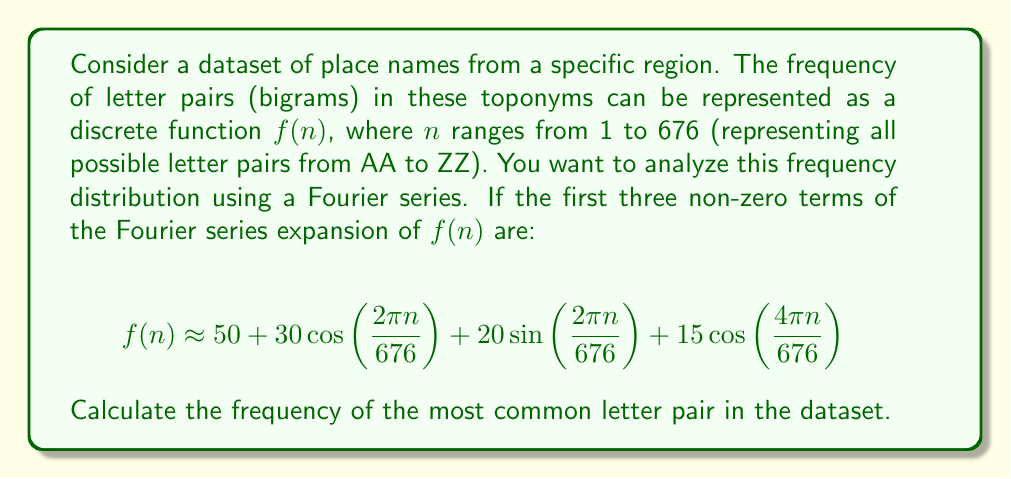Could you help me with this problem? To solve this problem, we need to understand the Fourier series representation and find the maximum value of the given function. Let's break it down step-by-step:

1) The given Fourier series approximation is:

   $$f(n) \approx 50 + 30\cos\left(\frac{2\pi n}{676}\right) + 20\sin\left(\frac{2\pi n}{676}\right) + 15\cos\left(\frac{4\pi n}{676}\right)$$

2) To find the maximum value, we need to consider the extreme values of the cosine and sine functions:
   - $\cos(x)$ has a maximum value of 1 when $x = 0, 2\pi, 4\pi, ...$
   - $\sin(x)$ has a maximum value of 1 when $x = \frac{\pi}{2}, \frac{5\pi}{2}, ...$

3) However, the cosine and sine terms have different frequencies, so they won't reach their maximum values simultaneously. We need to find the combination that gives the highest overall value.

4) The constant term 50 will always be present.

5) For the $\cos\left(\frac{2\pi n}{676}\right)$ term, the maximum contribution is 30 when $n = 0, 676, 1352, ...$

6) For the $\sin\left(\frac{2\pi n}{676}\right)$ term, the maximum contribution is 20 when $n = 169, 845, 1521, ...$

7) For the $\cos\left(\frac{4\pi n}{676}\right)$ term, the maximum contribution is 15 when $n = 0, 338, 676, ...$

8) The absolute maximum will occur when the first and third terms are at their maximum (when $n = 0$ or $676$), and the second term is as large as possible given this constraint.

9) When $n = 0$ or $676$, the function becomes:

   $$f(0) = f(676) = 50 + 30 + 0 + 15 = 95$$

Therefore, the maximum frequency, corresponding to the most common letter pair, is 95.
Answer: The frequency of the most common letter pair in the dataset is 95. 